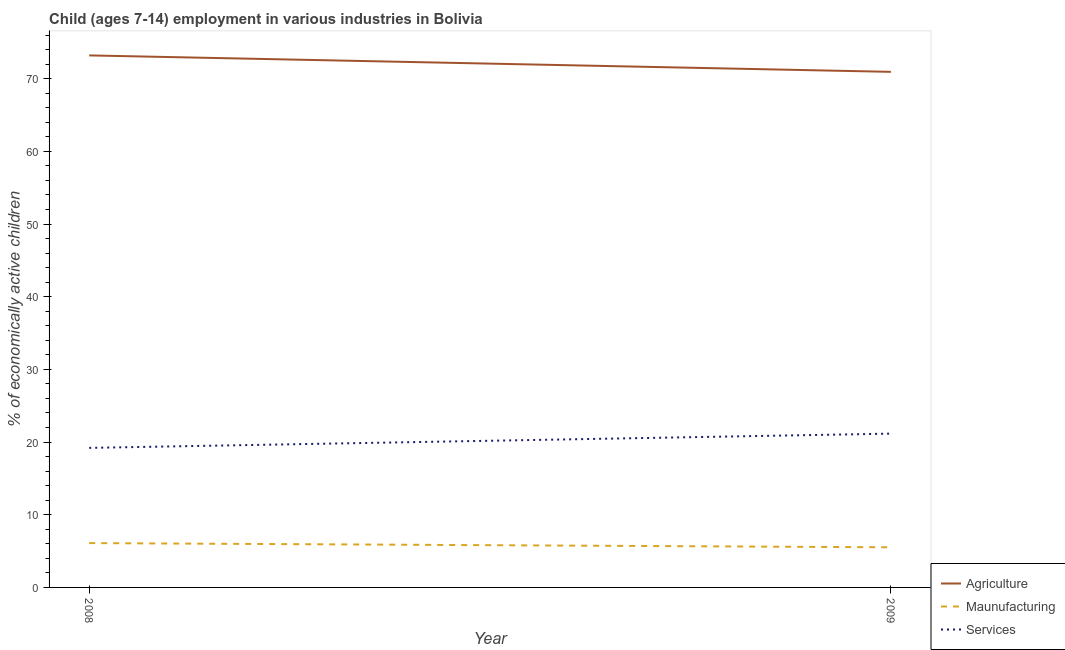What is the percentage of economically active children in agriculture in 2009?
Your response must be concise. 70.94. Across all years, what is the maximum percentage of economically active children in agriculture?
Keep it short and to the point. 73.2. Across all years, what is the minimum percentage of economically active children in agriculture?
Your answer should be compact. 70.94. What is the total percentage of economically active children in services in the graph?
Offer a terse response. 40.36. What is the difference between the percentage of economically active children in agriculture in 2008 and that in 2009?
Provide a short and direct response. 2.26. What is the difference between the percentage of economically active children in agriculture in 2008 and the percentage of economically active children in manufacturing in 2009?
Your answer should be very brief. 67.68. What is the average percentage of economically active children in manufacturing per year?
Ensure brevity in your answer.  5.81. In the year 2009, what is the difference between the percentage of economically active children in manufacturing and percentage of economically active children in services?
Offer a terse response. -15.64. What is the ratio of the percentage of economically active children in services in 2008 to that in 2009?
Ensure brevity in your answer.  0.91. Is it the case that in every year, the sum of the percentage of economically active children in agriculture and percentage of economically active children in manufacturing is greater than the percentage of economically active children in services?
Offer a terse response. Yes. Does the percentage of economically active children in manufacturing monotonically increase over the years?
Offer a very short reply. No. Is the percentage of economically active children in manufacturing strictly greater than the percentage of economically active children in agriculture over the years?
Your answer should be very brief. No. Are the values on the major ticks of Y-axis written in scientific E-notation?
Your answer should be very brief. No. Where does the legend appear in the graph?
Make the answer very short. Bottom right. How many legend labels are there?
Your answer should be very brief. 3. How are the legend labels stacked?
Make the answer very short. Vertical. What is the title of the graph?
Your answer should be compact. Child (ages 7-14) employment in various industries in Bolivia. What is the label or title of the Y-axis?
Your answer should be compact. % of economically active children. What is the % of economically active children of Agriculture in 2008?
Provide a short and direct response. 73.2. What is the % of economically active children in Services in 2008?
Provide a short and direct response. 19.2. What is the % of economically active children of Agriculture in 2009?
Your answer should be compact. 70.94. What is the % of economically active children of Maunufacturing in 2009?
Offer a very short reply. 5.52. What is the % of economically active children in Services in 2009?
Ensure brevity in your answer.  21.16. Across all years, what is the maximum % of economically active children of Agriculture?
Your response must be concise. 73.2. Across all years, what is the maximum % of economically active children of Services?
Your answer should be very brief. 21.16. Across all years, what is the minimum % of economically active children in Agriculture?
Provide a succinct answer. 70.94. Across all years, what is the minimum % of economically active children of Maunufacturing?
Give a very brief answer. 5.52. What is the total % of economically active children in Agriculture in the graph?
Keep it short and to the point. 144.14. What is the total % of economically active children of Maunufacturing in the graph?
Ensure brevity in your answer.  11.62. What is the total % of economically active children in Services in the graph?
Give a very brief answer. 40.36. What is the difference between the % of economically active children of Agriculture in 2008 and that in 2009?
Offer a very short reply. 2.26. What is the difference between the % of economically active children of Maunufacturing in 2008 and that in 2009?
Your response must be concise. 0.58. What is the difference between the % of economically active children in Services in 2008 and that in 2009?
Your response must be concise. -1.96. What is the difference between the % of economically active children of Agriculture in 2008 and the % of economically active children of Maunufacturing in 2009?
Make the answer very short. 67.68. What is the difference between the % of economically active children of Agriculture in 2008 and the % of economically active children of Services in 2009?
Keep it short and to the point. 52.04. What is the difference between the % of economically active children of Maunufacturing in 2008 and the % of economically active children of Services in 2009?
Your answer should be compact. -15.06. What is the average % of economically active children in Agriculture per year?
Provide a succinct answer. 72.07. What is the average % of economically active children in Maunufacturing per year?
Your answer should be compact. 5.81. What is the average % of economically active children in Services per year?
Your answer should be very brief. 20.18. In the year 2008, what is the difference between the % of economically active children of Agriculture and % of economically active children of Maunufacturing?
Provide a succinct answer. 67.1. In the year 2009, what is the difference between the % of economically active children in Agriculture and % of economically active children in Maunufacturing?
Make the answer very short. 65.42. In the year 2009, what is the difference between the % of economically active children in Agriculture and % of economically active children in Services?
Your answer should be compact. 49.78. In the year 2009, what is the difference between the % of economically active children in Maunufacturing and % of economically active children in Services?
Keep it short and to the point. -15.64. What is the ratio of the % of economically active children of Agriculture in 2008 to that in 2009?
Give a very brief answer. 1.03. What is the ratio of the % of economically active children in Maunufacturing in 2008 to that in 2009?
Offer a very short reply. 1.11. What is the ratio of the % of economically active children of Services in 2008 to that in 2009?
Provide a succinct answer. 0.91. What is the difference between the highest and the second highest % of economically active children of Agriculture?
Your response must be concise. 2.26. What is the difference between the highest and the second highest % of economically active children in Maunufacturing?
Provide a succinct answer. 0.58. What is the difference between the highest and the second highest % of economically active children of Services?
Make the answer very short. 1.96. What is the difference between the highest and the lowest % of economically active children of Agriculture?
Give a very brief answer. 2.26. What is the difference between the highest and the lowest % of economically active children in Maunufacturing?
Keep it short and to the point. 0.58. What is the difference between the highest and the lowest % of economically active children of Services?
Provide a succinct answer. 1.96. 